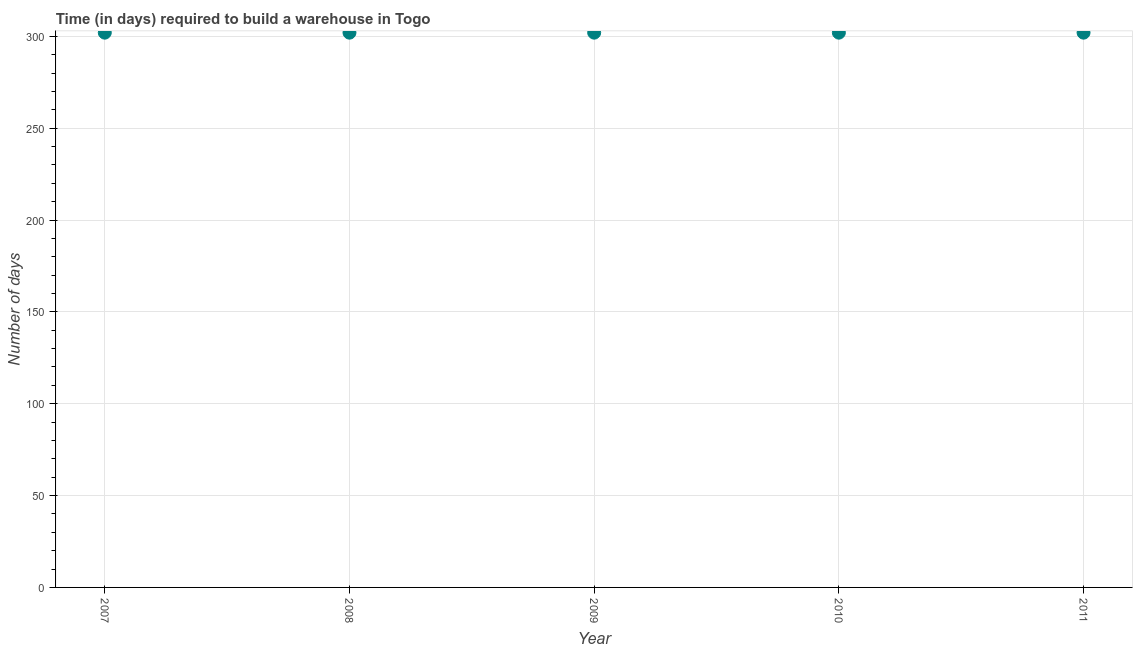What is the time required to build a warehouse in 2011?
Provide a succinct answer. 302. Across all years, what is the maximum time required to build a warehouse?
Give a very brief answer. 302. Across all years, what is the minimum time required to build a warehouse?
Offer a terse response. 302. What is the sum of the time required to build a warehouse?
Your answer should be compact. 1510. What is the average time required to build a warehouse per year?
Your response must be concise. 302. What is the median time required to build a warehouse?
Make the answer very short. 302. Do a majority of the years between 2009 and 2011 (inclusive) have time required to build a warehouse greater than 150 days?
Offer a very short reply. Yes. Is the sum of the time required to build a warehouse in 2007 and 2009 greater than the maximum time required to build a warehouse across all years?
Make the answer very short. Yes. What is the difference between the highest and the lowest time required to build a warehouse?
Provide a succinct answer. 0. What is the difference between two consecutive major ticks on the Y-axis?
Your answer should be compact. 50. Are the values on the major ticks of Y-axis written in scientific E-notation?
Offer a terse response. No. Does the graph contain any zero values?
Provide a short and direct response. No. What is the title of the graph?
Give a very brief answer. Time (in days) required to build a warehouse in Togo. What is the label or title of the X-axis?
Keep it short and to the point. Year. What is the label or title of the Y-axis?
Offer a terse response. Number of days. What is the Number of days in 2007?
Ensure brevity in your answer.  302. What is the Number of days in 2008?
Your response must be concise. 302. What is the Number of days in 2009?
Ensure brevity in your answer.  302. What is the Number of days in 2010?
Make the answer very short. 302. What is the Number of days in 2011?
Provide a succinct answer. 302. What is the difference between the Number of days in 2007 and 2008?
Offer a very short reply. 0. What is the difference between the Number of days in 2007 and 2011?
Offer a terse response. 0. What is the difference between the Number of days in 2008 and 2009?
Your answer should be compact. 0. What is the difference between the Number of days in 2008 and 2010?
Offer a very short reply. 0. What is the difference between the Number of days in 2008 and 2011?
Your answer should be compact. 0. What is the difference between the Number of days in 2009 and 2011?
Your answer should be compact. 0. What is the difference between the Number of days in 2010 and 2011?
Offer a very short reply. 0. What is the ratio of the Number of days in 2007 to that in 2011?
Make the answer very short. 1. What is the ratio of the Number of days in 2008 to that in 2009?
Offer a very short reply. 1. What is the ratio of the Number of days in 2009 to that in 2011?
Offer a very short reply. 1. What is the ratio of the Number of days in 2010 to that in 2011?
Keep it short and to the point. 1. 